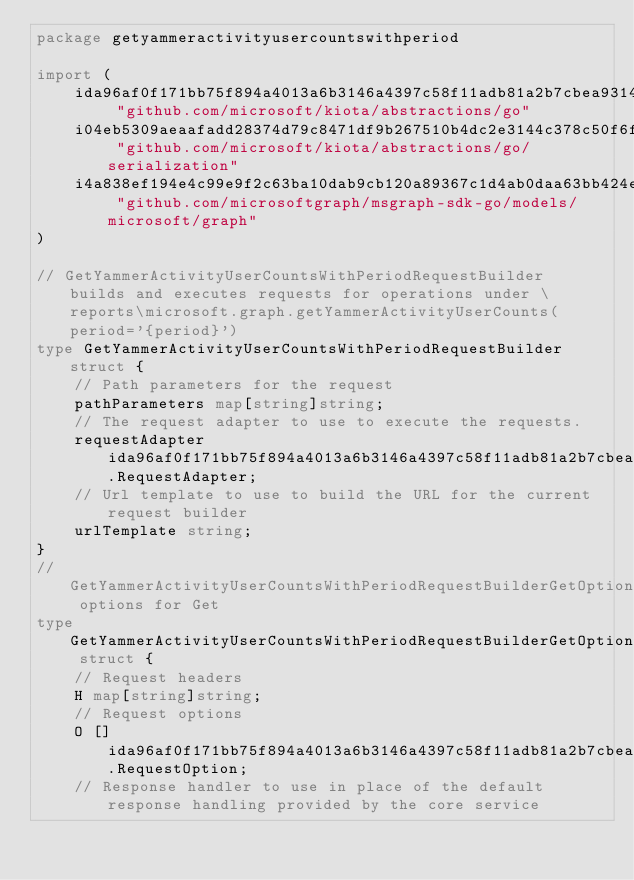<code> <loc_0><loc_0><loc_500><loc_500><_Go_>package getyammeractivityusercountswithperiod

import (
    ida96af0f171bb75f894a4013a6b3146a4397c58f11adb81a2b7cbea9314783a9 "github.com/microsoft/kiota/abstractions/go"
    i04eb5309aeaafadd28374d79c8471df9b267510b4dc2e3144c378c50f6fd7b55 "github.com/microsoft/kiota/abstractions/go/serialization"
    i4a838ef194e4c99e9f2c63ba10dab9cb120a89367c1d4ab0daa63bb424e20d87 "github.com/microsoftgraph/msgraph-sdk-go/models/microsoft/graph"
)

// GetYammerActivityUserCountsWithPeriodRequestBuilder builds and executes requests for operations under \reports\microsoft.graph.getYammerActivityUserCounts(period='{period}')
type GetYammerActivityUserCountsWithPeriodRequestBuilder struct {
    // Path parameters for the request
    pathParameters map[string]string;
    // The request adapter to use to execute the requests.
    requestAdapter ida96af0f171bb75f894a4013a6b3146a4397c58f11adb81a2b7cbea9314783a9.RequestAdapter;
    // Url template to use to build the URL for the current request builder
    urlTemplate string;
}
// GetYammerActivityUserCountsWithPeriodRequestBuilderGetOptions options for Get
type GetYammerActivityUserCountsWithPeriodRequestBuilderGetOptions struct {
    // Request headers
    H map[string]string;
    // Request options
    O []ida96af0f171bb75f894a4013a6b3146a4397c58f11adb81a2b7cbea9314783a9.RequestOption;
    // Response handler to use in place of the default response handling provided by the core service</code> 